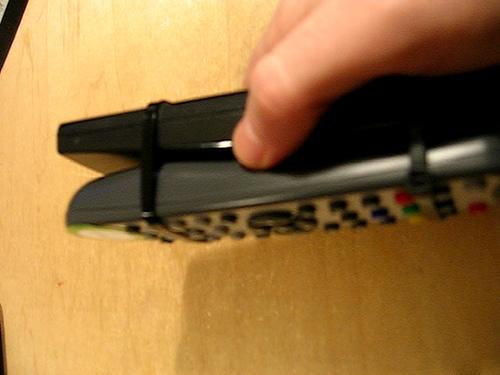Which part of the hand is fully in the picture?
Keep it brief. Thumb. Could these be remote controls?
Quick response, please. Yes. Is the hand in the picture a right or left hand?
Answer briefly. Right. 